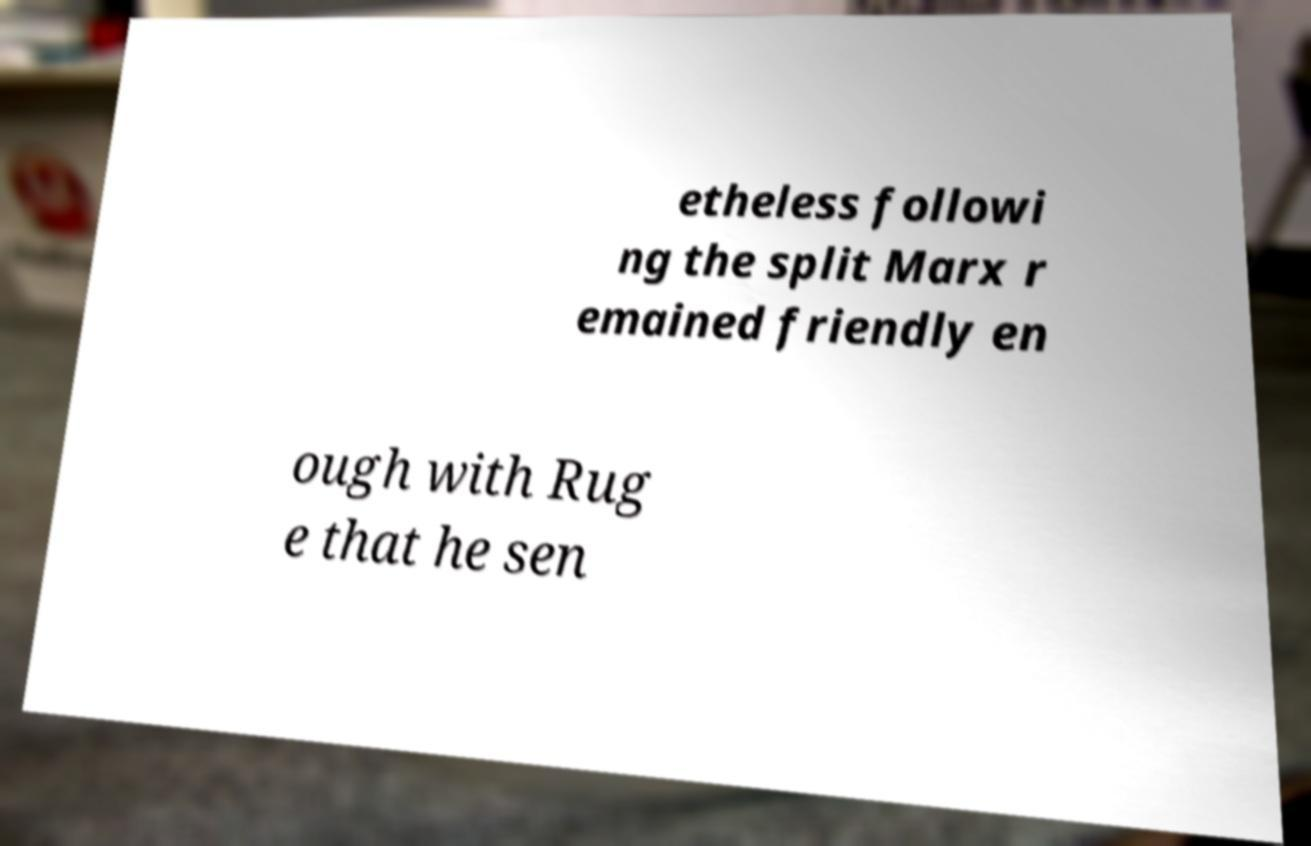Can you read and provide the text displayed in the image?This photo seems to have some interesting text. Can you extract and type it out for me? etheless followi ng the split Marx r emained friendly en ough with Rug e that he sen 